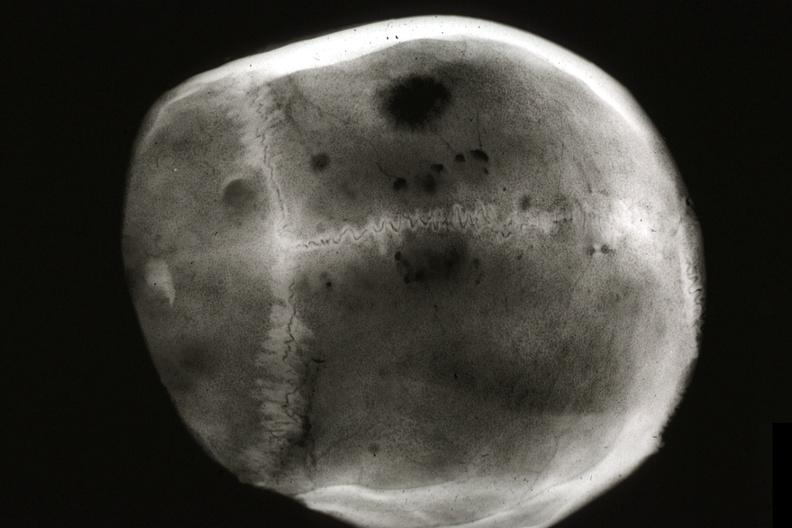what is present?
Answer the question using a single word or phrase. Metastatic carcinoma x-ray 